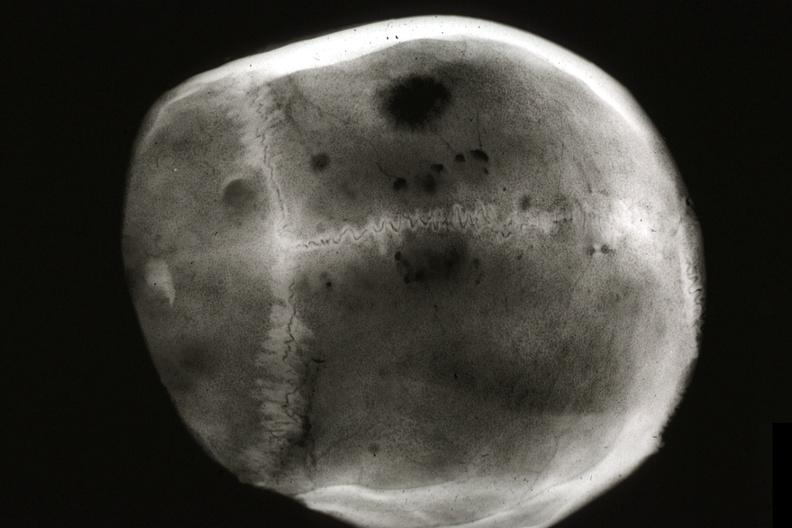what is present?
Answer the question using a single word or phrase. Metastatic carcinoma x-ray 